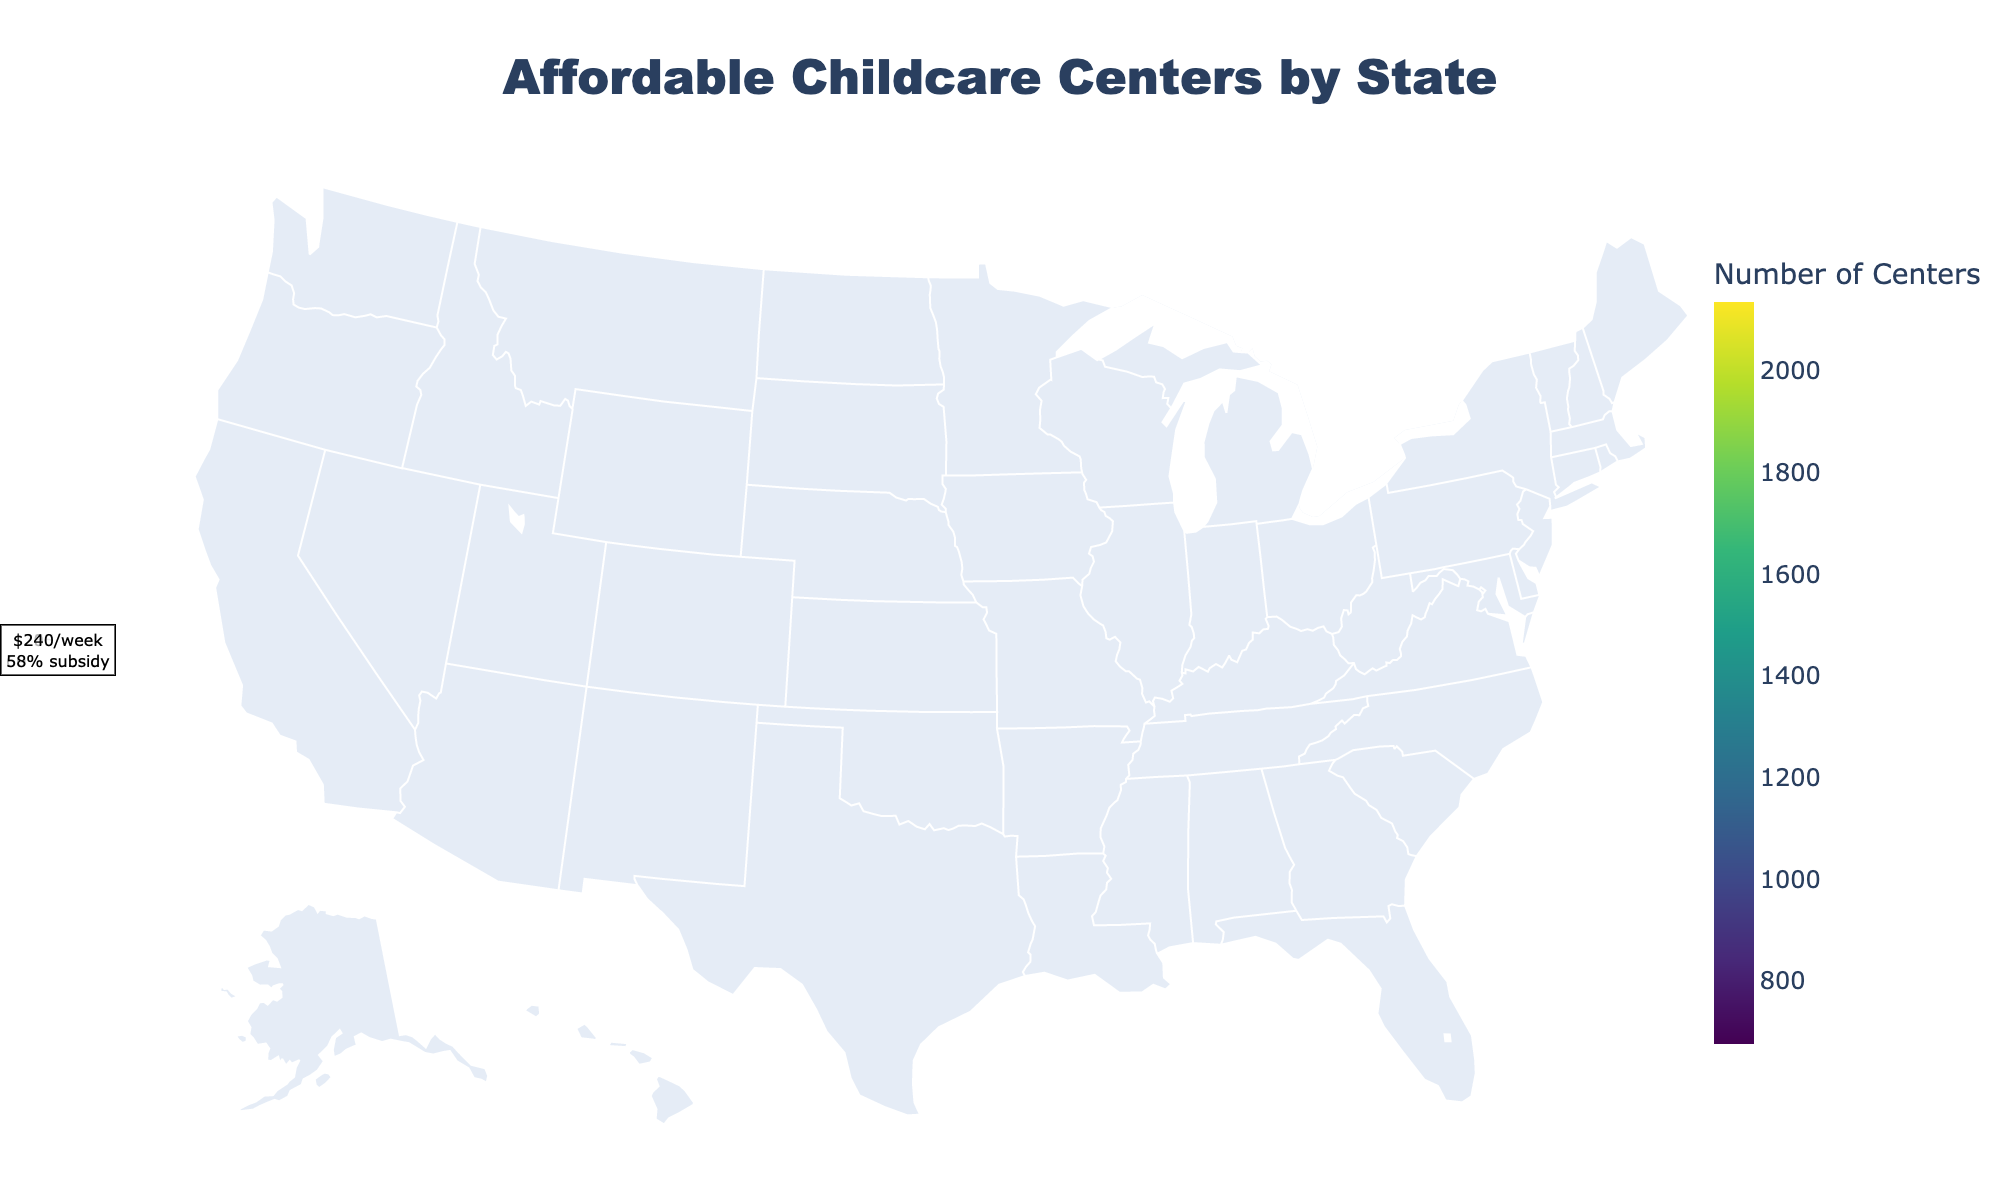Which state has the highest number of affordable childcare centers? The figure shows the number of affordable childcare centers for each state. California has the highest number of affordable childcare centers.
Answer: California What is the average weekly cost of childcare in Massachusetts? The annotations on the figure show the average weekly costs for each state. Massachusetts has an average weekly cost of $255.
Answer: $255 Which state offers the highest subsidy percentage for single parents? The annotations on the figure provide the subsidy percentages. Texas offers the highest single parent subsidy percentage at 70%.
Answer: Texas Compare the number of affordable childcare centers between Ohio and Michigan. Which state has more? The figure shows the number of affordable childcare centers. Ohio has 987 centers while Michigan has 934 centers. Ohio has more affordable childcare centers.
Answer: Ohio What is the average weekly cost of childcare in California compared to New York? The figure annotations indicate the weekly costs. California's weekly cost is $215 and New York's is $245. California's cost is lower.
Answer: California's cost is lower Which state has the least number of affordable childcare centers? The figure shows the number of affordable childcare centers for each state. New Jersey has the least number of affordable childcare centers at 678.
Answer: New Jersey Identify the state with the highest average weekly childcare cost. The annotations on the figure list the average weekly costs. Massachusetts has the highest average weekly childcare cost at $255.
Answer: Massachusetts What is the sum of affordable childcare centers in Texas and Florida? Texas has 1856 centers, and Florida has 1678 centers. Adding them up gives 1856 + 1678 = 3534.
Answer: 3534 How does Georgia's single parent subsidy percentage compare to Illinois'? The annotations show that Georgia's subsidy percentage is 59% and Illinois' is 62%. Illinois offers a higher subsidy percentage.
Answer: Illinois offers a higher subsidy Which state has a lower average weekly childcare cost: North Carolina or Washington? The annotations indicate that North Carolina's cost is $170 and Washington's is $230. North Carolina has the lower cost.
Answer: North Carolina 